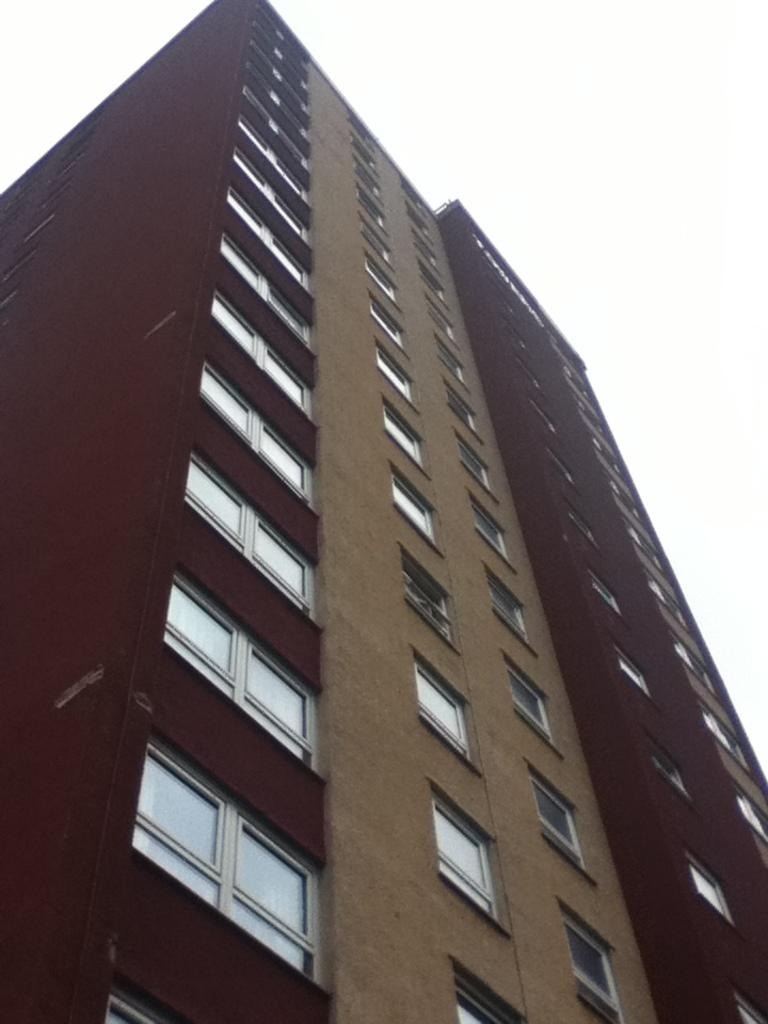What type of structure is present in the image? There is a building in the image. What feature can be seen on the building? The building has windows. What is visible at the top of the image? The sky is visible at the top of the image. Where is the doctor standing with a bucket in the image? There is no doctor or bucket present in the image. What type of lipstick is the person wearing in the image? There is no person or lipstick visible in the image. 